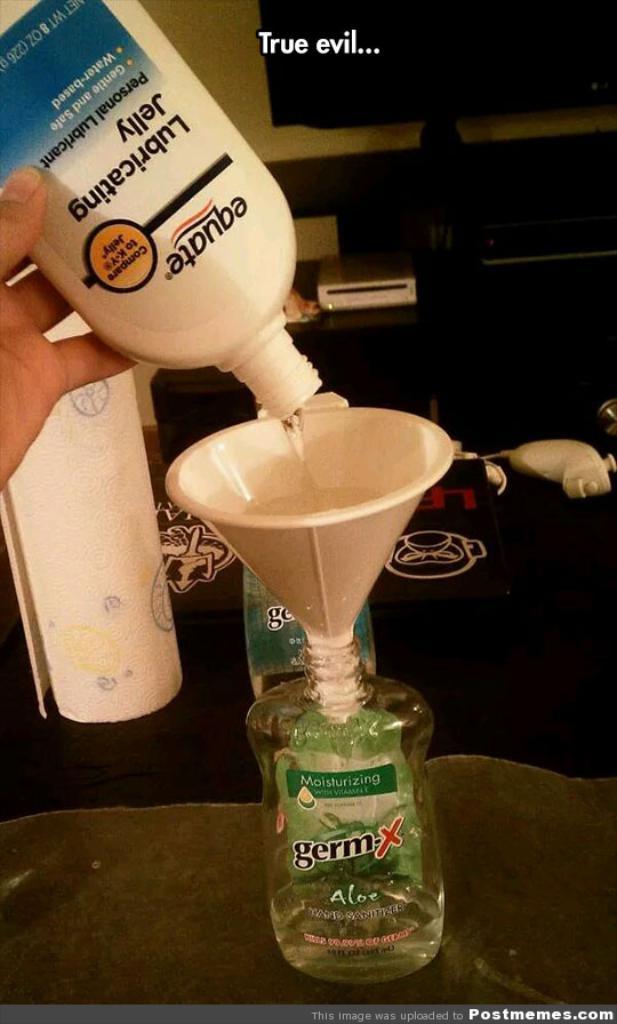What is being poured into a funnel?
Give a very brief answer. Lubricating jelly. 